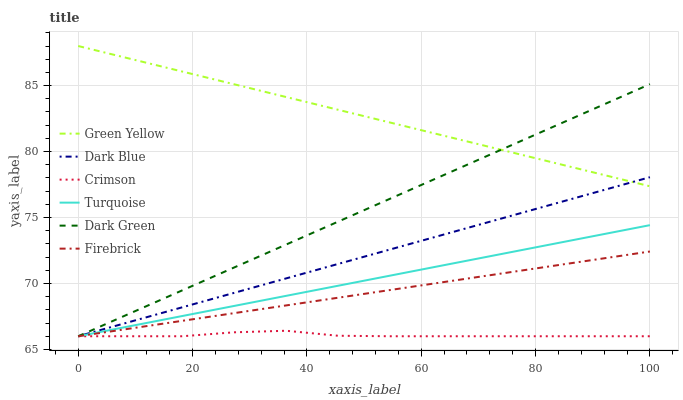Does Crimson have the minimum area under the curve?
Answer yes or no. Yes. Does Green Yellow have the maximum area under the curve?
Answer yes or no. Yes. Does Firebrick have the minimum area under the curve?
Answer yes or no. No. Does Firebrick have the maximum area under the curve?
Answer yes or no. No. Is Green Yellow the smoothest?
Answer yes or no. Yes. Is Crimson the roughest?
Answer yes or no. Yes. Is Firebrick the smoothest?
Answer yes or no. No. Is Firebrick the roughest?
Answer yes or no. No. Does Turquoise have the lowest value?
Answer yes or no. Yes. Does Green Yellow have the lowest value?
Answer yes or no. No. Does Green Yellow have the highest value?
Answer yes or no. Yes. Does Firebrick have the highest value?
Answer yes or no. No. Is Firebrick less than Green Yellow?
Answer yes or no. Yes. Is Green Yellow greater than Turquoise?
Answer yes or no. Yes. Does Turquoise intersect Firebrick?
Answer yes or no. Yes. Is Turquoise less than Firebrick?
Answer yes or no. No. Is Turquoise greater than Firebrick?
Answer yes or no. No. Does Firebrick intersect Green Yellow?
Answer yes or no. No. 